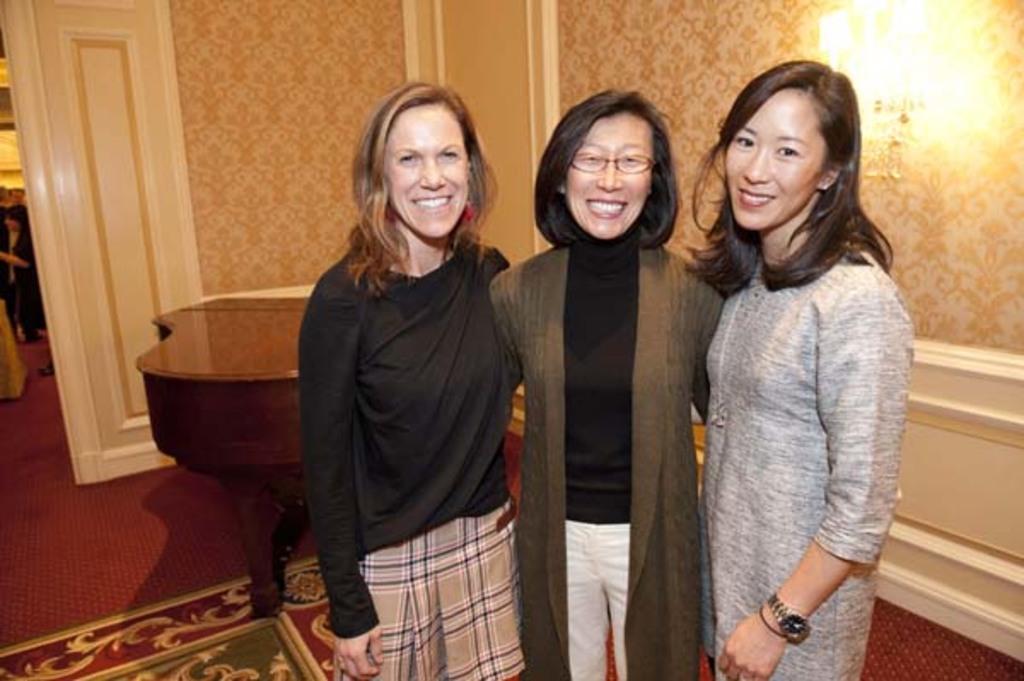How would you summarize this image in a sentence or two? In the front three women are standing and smiling. Floor with carpet. In the background we can see walls, people, table and light. Light is on the wall. 